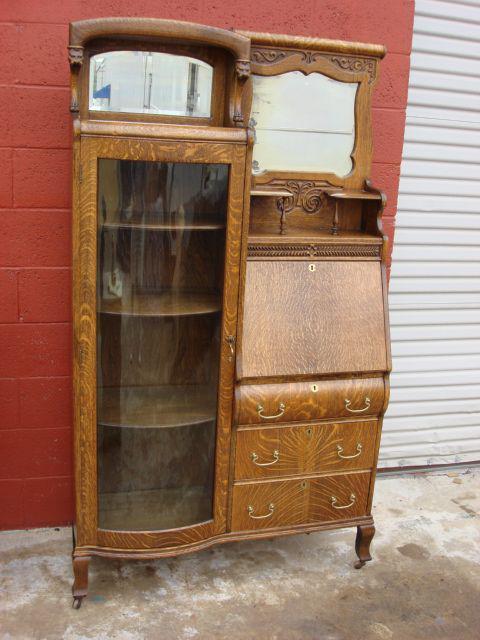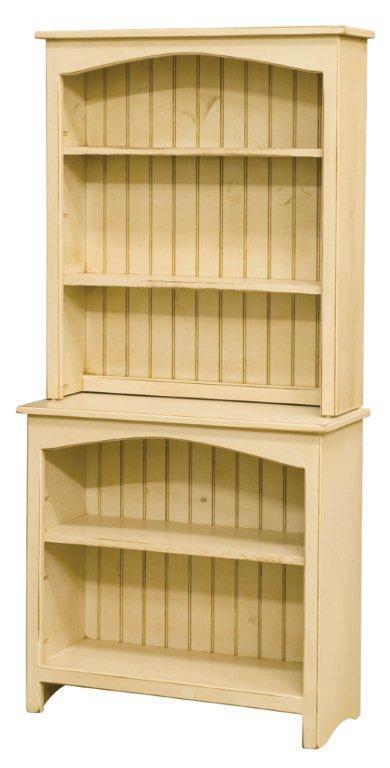The first image is the image on the left, the second image is the image on the right. Given the left and right images, does the statement "there is a cabinet with a glass door n the left and a mirror and 3 drawers on the right" hold true? Answer yes or no. Yes. The first image is the image on the left, the second image is the image on the right. Considering the images on both sides, is "The hutch has side by side doors with window panels." valid? Answer yes or no. No. 